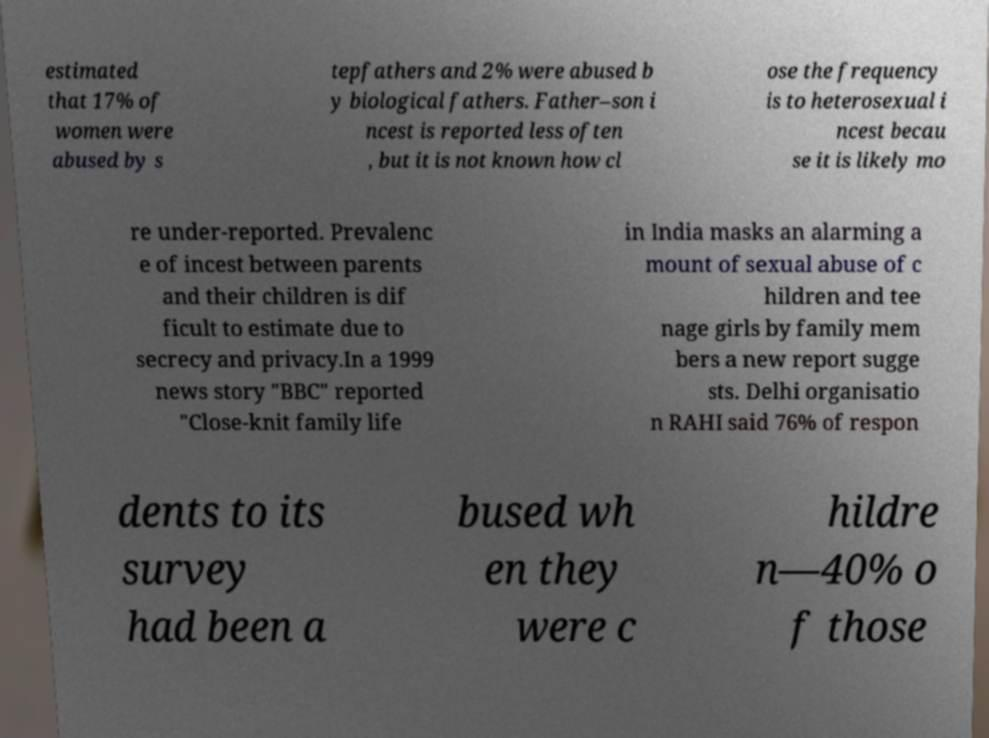I need the written content from this picture converted into text. Can you do that? estimated that 17% of women were abused by s tepfathers and 2% were abused b y biological fathers. Father–son i ncest is reported less often , but it is not known how cl ose the frequency is to heterosexual i ncest becau se it is likely mo re under-reported. Prevalenc e of incest between parents and their children is dif ficult to estimate due to secrecy and privacy.In a 1999 news story "BBC" reported "Close-knit family life in India masks an alarming a mount of sexual abuse of c hildren and tee nage girls by family mem bers a new report sugge sts. Delhi organisatio n RAHI said 76% of respon dents to its survey had been a bused wh en they were c hildre n—40% o f those 